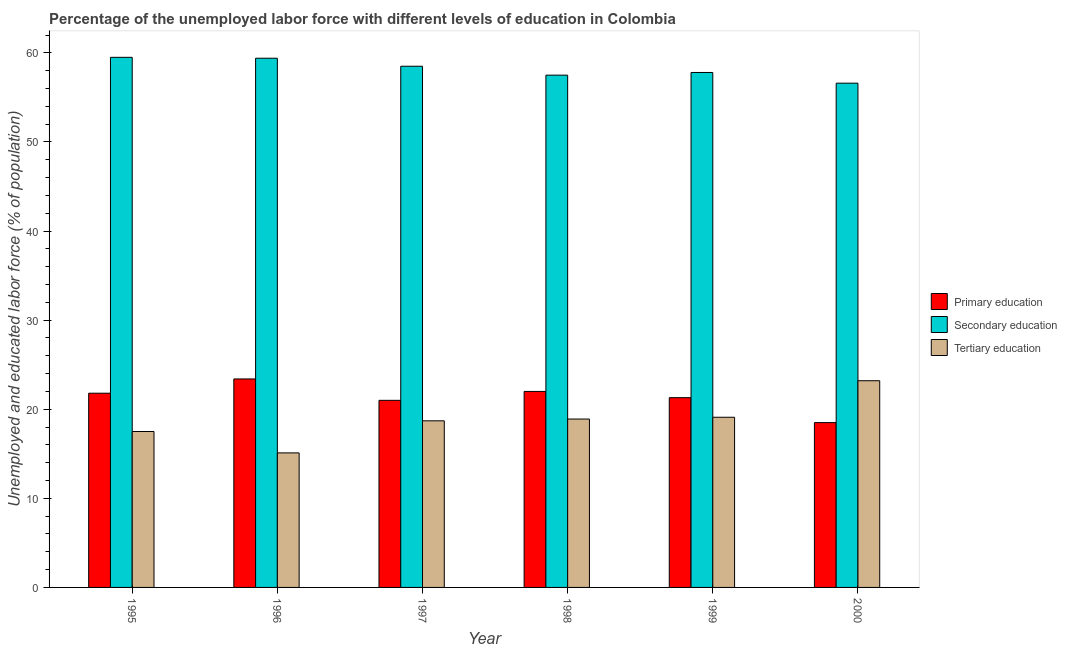How many different coloured bars are there?
Your response must be concise. 3. How many bars are there on the 1st tick from the right?
Provide a succinct answer. 3. What is the percentage of labor force who received tertiary education in 1997?
Provide a short and direct response. 18.7. Across all years, what is the maximum percentage of labor force who received tertiary education?
Ensure brevity in your answer.  23.2. Across all years, what is the minimum percentage of labor force who received primary education?
Offer a very short reply. 18.5. What is the total percentage of labor force who received secondary education in the graph?
Keep it short and to the point. 349.3. What is the difference between the percentage of labor force who received secondary education in 1995 and that in 2000?
Your response must be concise. 2.9. What is the difference between the percentage of labor force who received tertiary education in 2000 and the percentage of labor force who received primary education in 1995?
Offer a very short reply. 5.7. What is the average percentage of labor force who received tertiary education per year?
Offer a terse response. 18.75. In the year 1999, what is the difference between the percentage of labor force who received tertiary education and percentage of labor force who received secondary education?
Keep it short and to the point. 0. What is the ratio of the percentage of labor force who received secondary education in 1995 to that in 1999?
Offer a very short reply. 1.03. Is the percentage of labor force who received secondary education in 1995 less than that in 1996?
Keep it short and to the point. No. What is the difference between the highest and the second highest percentage of labor force who received primary education?
Keep it short and to the point. 1.4. What is the difference between the highest and the lowest percentage of labor force who received primary education?
Provide a succinct answer. 4.9. In how many years, is the percentage of labor force who received tertiary education greater than the average percentage of labor force who received tertiary education taken over all years?
Your answer should be compact. 3. Is the sum of the percentage of labor force who received primary education in 1995 and 1996 greater than the maximum percentage of labor force who received secondary education across all years?
Make the answer very short. Yes. What does the 2nd bar from the left in 1997 represents?
Keep it short and to the point. Secondary education. What does the 2nd bar from the right in 1998 represents?
Give a very brief answer. Secondary education. Is it the case that in every year, the sum of the percentage of labor force who received primary education and percentage of labor force who received secondary education is greater than the percentage of labor force who received tertiary education?
Your response must be concise. Yes. How many years are there in the graph?
Ensure brevity in your answer.  6. Are the values on the major ticks of Y-axis written in scientific E-notation?
Offer a terse response. No. Does the graph contain any zero values?
Your answer should be compact. No. Does the graph contain grids?
Offer a terse response. No. How many legend labels are there?
Your answer should be compact. 3. How are the legend labels stacked?
Your answer should be compact. Vertical. What is the title of the graph?
Offer a very short reply. Percentage of the unemployed labor force with different levels of education in Colombia. Does "Labor Market" appear as one of the legend labels in the graph?
Offer a very short reply. No. What is the label or title of the X-axis?
Your answer should be very brief. Year. What is the label or title of the Y-axis?
Ensure brevity in your answer.  Unemployed and educated labor force (% of population). What is the Unemployed and educated labor force (% of population) of Primary education in 1995?
Make the answer very short. 21.8. What is the Unemployed and educated labor force (% of population) in Secondary education in 1995?
Offer a terse response. 59.5. What is the Unemployed and educated labor force (% of population) of Tertiary education in 1995?
Make the answer very short. 17.5. What is the Unemployed and educated labor force (% of population) in Primary education in 1996?
Your answer should be compact. 23.4. What is the Unemployed and educated labor force (% of population) of Secondary education in 1996?
Ensure brevity in your answer.  59.4. What is the Unemployed and educated labor force (% of population) in Tertiary education in 1996?
Give a very brief answer. 15.1. What is the Unemployed and educated labor force (% of population) of Primary education in 1997?
Offer a very short reply. 21. What is the Unemployed and educated labor force (% of population) of Secondary education in 1997?
Your response must be concise. 58.5. What is the Unemployed and educated labor force (% of population) in Tertiary education in 1997?
Keep it short and to the point. 18.7. What is the Unemployed and educated labor force (% of population) in Primary education in 1998?
Provide a succinct answer. 22. What is the Unemployed and educated labor force (% of population) in Secondary education in 1998?
Make the answer very short. 57.5. What is the Unemployed and educated labor force (% of population) of Tertiary education in 1998?
Keep it short and to the point. 18.9. What is the Unemployed and educated labor force (% of population) in Primary education in 1999?
Keep it short and to the point. 21.3. What is the Unemployed and educated labor force (% of population) in Secondary education in 1999?
Ensure brevity in your answer.  57.8. What is the Unemployed and educated labor force (% of population) in Tertiary education in 1999?
Keep it short and to the point. 19.1. What is the Unemployed and educated labor force (% of population) of Primary education in 2000?
Keep it short and to the point. 18.5. What is the Unemployed and educated labor force (% of population) in Secondary education in 2000?
Make the answer very short. 56.6. What is the Unemployed and educated labor force (% of population) in Tertiary education in 2000?
Your response must be concise. 23.2. Across all years, what is the maximum Unemployed and educated labor force (% of population) in Primary education?
Your response must be concise. 23.4. Across all years, what is the maximum Unemployed and educated labor force (% of population) of Secondary education?
Make the answer very short. 59.5. Across all years, what is the maximum Unemployed and educated labor force (% of population) in Tertiary education?
Offer a very short reply. 23.2. Across all years, what is the minimum Unemployed and educated labor force (% of population) of Secondary education?
Make the answer very short. 56.6. Across all years, what is the minimum Unemployed and educated labor force (% of population) of Tertiary education?
Keep it short and to the point. 15.1. What is the total Unemployed and educated labor force (% of population) of Primary education in the graph?
Provide a succinct answer. 128. What is the total Unemployed and educated labor force (% of population) in Secondary education in the graph?
Offer a terse response. 349.3. What is the total Unemployed and educated labor force (% of population) in Tertiary education in the graph?
Give a very brief answer. 112.5. What is the difference between the Unemployed and educated labor force (% of population) in Primary education in 1995 and that in 1996?
Keep it short and to the point. -1.6. What is the difference between the Unemployed and educated labor force (% of population) of Tertiary education in 1995 and that in 1996?
Your answer should be compact. 2.4. What is the difference between the Unemployed and educated labor force (% of population) of Tertiary education in 1995 and that in 1997?
Offer a very short reply. -1.2. What is the difference between the Unemployed and educated labor force (% of population) of Primary education in 1995 and that in 1998?
Your answer should be very brief. -0.2. What is the difference between the Unemployed and educated labor force (% of population) in Secondary education in 1995 and that in 1999?
Keep it short and to the point. 1.7. What is the difference between the Unemployed and educated labor force (% of population) in Tertiary education in 1995 and that in 1999?
Ensure brevity in your answer.  -1.6. What is the difference between the Unemployed and educated labor force (% of population) in Primary education in 1995 and that in 2000?
Offer a very short reply. 3.3. What is the difference between the Unemployed and educated labor force (% of population) of Secondary education in 1995 and that in 2000?
Give a very brief answer. 2.9. What is the difference between the Unemployed and educated labor force (% of population) in Primary education in 1996 and that in 1997?
Provide a succinct answer. 2.4. What is the difference between the Unemployed and educated labor force (% of population) of Secondary education in 1996 and that in 1997?
Provide a succinct answer. 0.9. What is the difference between the Unemployed and educated labor force (% of population) of Primary education in 1996 and that in 1998?
Offer a terse response. 1.4. What is the difference between the Unemployed and educated labor force (% of population) of Secondary education in 1996 and that in 1998?
Offer a very short reply. 1.9. What is the difference between the Unemployed and educated labor force (% of population) in Primary education in 1996 and that in 1999?
Make the answer very short. 2.1. What is the difference between the Unemployed and educated labor force (% of population) of Secondary education in 1996 and that in 1999?
Your answer should be compact. 1.6. What is the difference between the Unemployed and educated labor force (% of population) of Tertiary education in 1996 and that in 1999?
Your response must be concise. -4. What is the difference between the Unemployed and educated labor force (% of population) of Primary education in 1996 and that in 2000?
Keep it short and to the point. 4.9. What is the difference between the Unemployed and educated labor force (% of population) of Secondary education in 1996 and that in 2000?
Give a very brief answer. 2.8. What is the difference between the Unemployed and educated labor force (% of population) in Primary education in 1997 and that in 1998?
Keep it short and to the point. -1. What is the difference between the Unemployed and educated labor force (% of population) of Tertiary education in 1997 and that in 1998?
Give a very brief answer. -0.2. What is the difference between the Unemployed and educated labor force (% of population) of Primary education in 1997 and that in 1999?
Your answer should be very brief. -0.3. What is the difference between the Unemployed and educated labor force (% of population) of Tertiary education in 1997 and that in 1999?
Keep it short and to the point. -0.4. What is the difference between the Unemployed and educated labor force (% of population) in Primary education in 1997 and that in 2000?
Provide a short and direct response. 2.5. What is the difference between the Unemployed and educated labor force (% of population) of Tertiary education in 1997 and that in 2000?
Keep it short and to the point. -4.5. What is the difference between the Unemployed and educated labor force (% of population) in Tertiary education in 1998 and that in 1999?
Your response must be concise. -0.2. What is the difference between the Unemployed and educated labor force (% of population) in Primary education in 1998 and that in 2000?
Keep it short and to the point. 3.5. What is the difference between the Unemployed and educated labor force (% of population) of Tertiary education in 1998 and that in 2000?
Make the answer very short. -4.3. What is the difference between the Unemployed and educated labor force (% of population) in Primary education in 1999 and that in 2000?
Provide a short and direct response. 2.8. What is the difference between the Unemployed and educated labor force (% of population) of Tertiary education in 1999 and that in 2000?
Keep it short and to the point. -4.1. What is the difference between the Unemployed and educated labor force (% of population) in Primary education in 1995 and the Unemployed and educated labor force (% of population) in Secondary education in 1996?
Provide a short and direct response. -37.6. What is the difference between the Unemployed and educated labor force (% of population) in Secondary education in 1995 and the Unemployed and educated labor force (% of population) in Tertiary education in 1996?
Offer a terse response. 44.4. What is the difference between the Unemployed and educated labor force (% of population) of Primary education in 1995 and the Unemployed and educated labor force (% of population) of Secondary education in 1997?
Provide a succinct answer. -36.7. What is the difference between the Unemployed and educated labor force (% of population) in Primary education in 1995 and the Unemployed and educated labor force (% of population) in Tertiary education in 1997?
Make the answer very short. 3.1. What is the difference between the Unemployed and educated labor force (% of population) in Secondary education in 1995 and the Unemployed and educated labor force (% of population) in Tertiary education in 1997?
Make the answer very short. 40.8. What is the difference between the Unemployed and educated labor force (% of population) of Primary education in 1995 and the Unemployed and educated labor force (% of population) of Secondary education in 1998?
Ensure brevity in your answer.  -35.7. What is the difference between the Unemployed and educated labor force (% of population) in Primary education in 1995 and the Unemployed and educated labor force (% of population) in Tertiary education in 1998?
Your answer should be very brief. 2.9. What is the difference between the Unemployed and educated labor force (% of population) of Secondary education in 1995 and the Unemployed and educated labor force (% of population) of Tertiary education in 1998?
Your answer should be very brief. 40.6. What is the difference between the Unemployed and educated labor force (% of population) of Primary education in 1995 and the Unemployed and educated labor force (% of population) of Secondary education in 1999?
Keep it short and to the point. -36. What is the difference between the Unemployed and educated labor force (% of population) in Secondary education in 1995 and the Unemployed and educated labor force (% of population) in Tertiary education in 1999?
Your response must be concise. 40.4. What is the difference between the Unemployed and educated labor force (% of population) in Primary education in 1995 and the Unemployed and educated labor force (% of population) in Secondary education in 2000?
Ensure brevity in your answer.  -34.8. What is the difference between the Unemployed and educated labor force (% of population) of Secondary education in 1995 and the Unemployed and educated labor force (% of population) of Tertiary education in 2000?
Your answer should be compact. 36.3. What is the difference between the Unemployed and educated labor force (% of population) in Primary education in 1996 and the Unemployed and educated labor force (% of population) in Secondary education in 1997?
Keep it short and to the point. -35.1. What is the difference between the Unemployed and educated labor force (% of population) of Secondary education in 1996 and the Unemployed and educated labor force (% of population) of Tertiary education in 1997?
Give a very brief answer. 40.7. What is the difference between the Unemployed and educated labor force (% of population) of Primary education in 1996 and the Unemployed and educated labor force (% of population) of Secondary education in 1998?
Your response must be concise. -34.1. What is the difference between the Unemployed and educated labor force (% of population) in Primary education in 1996 and the Unemployed and educated labor force (% of population) in Tertiary education in 1998?
Offer a very short reply. 4.5. What is the difference between the Unemployed and educated labor force (% of population) in Secondary education in 1996 and the Unemployed and educated labor force (% of population) in Tertiary education in 1998?
Give a very brief answer. 40.5. What is the difference between the Unemployed and educated labor force (% of population) in Primary education in 1996 and the Unemployed and educated labor force (% of population) in Secondary education in 1999?
Your response must be concise. -34.4. What is the difference between the Unemployed and educated labor force (% of population) of Primary education in 1996 and the Unemployed and educated labor force (% of population) of Tertiary education in 1999?
Offer a very short reply. 4.3. What is the difference between the Unemployed and educated labor force (% of population) of Secondary education in 1996 and the Unemployed and educated labor force (% of population) of Tertiary education in 1999?
Your answer should be very brief. 40.3. What is the difference between the Unemployed and educated labor force (% of population) in Primary education in 1996 and the Unemployed and educated labor force (% of population) in Secondary education in 2000?
Keep it short and to the point. -33.2. What is the difference between the Unemployed and educated labor force (% of population) of Primary education in 1996 and the Unemployed and educated labor force (% of population) of Tertiary education in 2000?
Offer a terse response. 0.2. What is the difference between the Unemployed and educated labor force (% of population) in Secondary education in 1996 and the Unemployed and educated labor force (% of population) in Tertiary education in 2000?
Your answer should be very brief. 36.2. What is the difference between the Unemployed and educated labor force (% of population) of Primary education in 1997 and the Unemployed and educated labor force (% of population) of Secondary education in 1998?
Ensure brevity in your answer.  -36.5. What is the difference between the Unemployed and educated labor force (% of population) in Secondary education in 1997 and the Unemployed and educated labor force (% of population) in Tertiary education in 1998?
Your response must be concise. 39.6. What is the difference between the Unemployed and educated labor force (% of population) in Primary education in 1997 and the Unemployed and educated labor force (% of population) in Secondary education in 1999?
Ensure brevity in your answer.  -36.8. What is the difference between the Unemployed and educated labor force (% of population) in Primary education in 1997 and the Unemployed and educated labor force (% of population) in Tertiary education in 1999?
Offer a very short reply. 1.9. What is the difference between the Unemployed and educated labor force (% of population) in Secondary education in 1997 and the Unemployed and educated labor force (% of population) in Tertiary education in 1999?
Offer a very short reply. 39.4. What is the difference between the Unemployed and educated labor force (% of population) of Primary education in 1997 and the Unemployed and educated labor force (% of population) of Secondary education in 2000?
Your response must be concise. -35.6. What is the difference between the Unemployed and educated labor force (% of population) in Primary education in 1997 and the Unemployed and educated labor force (% of population) in Tertiary education in 2000?
Offer a terse response. -2.2. What is the difference between the Unemployed and educated labor force (% of population) of Secondary education in 1997 and the Unemployed and educated labor force (% of population) of Tertiary education in 2000?
Offer a very short reply. 35.3. What is the difference between the Unemployed and educated labor force (% of population) in Primary education in 1998 and the Unemployed and educated labor force (% of population) in Secondary education in 1999?
Your answer should be very brief. -35.8. What is the difference between the Unemployed and educated labor force (% of population) in Primary education in 1998 and the Unemployed and educated labor force (% of population) in Tertiary education in 1999?
Ensure brevity in your answer.  2.9. What is the difference between the Unemployed and educated labor force (% of population) of Secondary education in 1998 and the Unemployed and educated labor force (% of population) of Tertiary education in 1999?
Keep it short and to the point. 38.4. What is the difference between the Unemployed and educated labor force (% of population) in Primary education in 1998 and the Unemployed and educated labor force (% of population) in Secondary education in 2000?
Offer a very short reply. -34.6. What is the difference between the Unemployed and educated labor force (% of population) of Secondary education in 1998 and the Unemployed and educated labor force (% of population) of Tertiary education in 2000?
Give a very brief answer. 34.3. What is the difference between the Unemployed and educated labor force (% of population) of Primary education in 1999 and the Unemployed and educated labor force (% of population) of Secondary education in 2000?
Make the answer very short. -35.3. What is the difference between the Unemployed and educated labor force (% of population) in Primary education in 1999 and the Unemployed and educated labor force (% of population) in Tertiary education in 2000?
Keep it short and to the point. -1.9. What is the difference between the Unemployed and educated labor force (% of population) of Secondary education in 1999 and the Unemployed and educated labor force (% of population) of Tertiary education in 2000?
Provide a short and direct response. 34.6. What is the average Unemployed and educated labor force (% of population) of Primary education per year?
Offer a terse response. 21.33. What is the average Unemployed and educated labor force (% of population) in Secondary education per year?
Offer a terse response. 58.22. What is the average Unemployed and educated labor force (% of population) in Tertiary education per year?
Ensure brevity in your answer.  18.75. In the year 1995, what is the difference between the Unemployed and educated labor force (% of population) in Primary education and Unemployed and educated labor force (% of population) in Secondary education?
Ensure brevity in your answer.  -37.7. In the year 1995, what is the difference between the Unemployed and educated labor force (% of population) of Secondary education and Unemployed and educated labor force (% of population) of Tertiary education?
Give a very brief answer. 42. In the year 1996, what is the difference between the Unemployed and educated labor force (% of population) of Primary education and Unemployed and educated labor force (% of population) of Secondary education?
Provide a succinct answer. -36. In the year 1996, what is the difference between the Unemployed and educated labor force (% of population) of Secondary education and Unemployed and educated labor force (% of population) of Tertiary education?
Offer a terse response. 44.3. In the year 1997, what is the difference between the Unemployed and educated labor force (% of population) of Primary education and Unemployed and educated labor force (% of population) of Secondary education?
Give a very brief answer. -37.5. In the year 1997, what is the difference between the Unemployed and educated labor force (% of population) in Primary education and Unemployed and educated labor force (% of population) in Tertiary education?
Make the answer very short. 2.3. In the year 1997, what is the difference between the Unemployed and educated labor force (% of population) in Secondary education and Unemployed and educated labor force (% of population) in Tertiary education?
Provide a short and direct response. 39.8. In the year 1998, what is the difference between the Unemployed and educated labor force (% of population) in Primary education and Unemployed and educated labor force (% of population) in Secondary education?
Offer a terse response. -35.5. In the year 1998, what is the difference between the Unemployed and educated labor force (% of population) in Secondary education and Unemployed and educated labor force (% of population) in Tertiary education?
Ensure brevity in your answer.  38.6. In the year 1999, what is the difference between the Unemployed and educated labor force (% of population) of Primary education and Unemployed and educated labor force (% of population) of Secondary education?
Keep it short and to the point. -36.5. In the year 1999, what is the difference between the Unemployed and educated labor force (% of population) in Primary education and Unemployed and educated labor force (% of population) in Tertiary education?
Give a very brief answer. 2.2. In the year 1999, what is the difference between the Unemployed and educated labor force (% of population) of Secondary education and Unemployed and educated labor force (% of population) of Tertiary education?
Keep it short and to the point. 38.7. In the year 2000, what is the difference between the Unemployed and educated labor force (% of population) in Primary education and Unemployed and educated labor force (% of population) in Secondary education?
Your answer should be compact. -38.1. In the year 2000, what is the difference between the Unemployed and educated labor force (% of population) of Primary education and Unemployed and educated labor force (% of population) of Tertiary education?
Offer a very short reply. -4.7. In the year 2000, what is the difference between the Unemployed and educated labor force (% of population) in Secondary education and Unemployed and educated labor force (% of population) in Tertiary education?
Keep it short and to the point. 33.4. What is the ratio of the Unemployed and educated labor force (% of population) of Primary education in 1995 to that in 1996?
Your answer should be very brief. 0.93. What is the ratio of the Unemployed and educated labor force (% of population) of Secondary education in 1995 to that in 1996?
Your answer should be very brief. 1. What is the ratio of the Unemployed and educated labor force (% of population) of Tertiary education in 1995 to that in 1996?
Your answer should be very brief. 1.16. What is the ratio of the Unemployed and educated labor force (% of population) of Primary education in 1995 to that in 1997?
Offer a terse response. 1.04. What is the ratio of the Unemployed and educated labor force (% of population) in Secondary education in 1995 to that in 1997?
Your answer should be compact. 1.02. What is the ratio of the Unemployed and educated labor force (% of population) in Tertiary education in 1995 to that in 1997?
Your answer should be compact. 0.94. What is the ratio of the Unemployed and educated labor force (% of population) of Primary education in 1995 to that in 1998?
Keep it short and to the point. 0.99. What is the ratio of the Unemployed and educated labor force (% of population) of Secondary education in 1995 to that in 1998?
Give a very brief answer. 1.03. What is the ratio of the Unemployed and educated labor force (% of population) of Tertiary education in 1995 to that in 1998?
Ensure brevity in your answer.  0.93. What is the ratio of the Unemployed and educated labor force (% of population) of Primary education in 1995 to that in 1999?
Your response must be concise. 1.02. What is the ratio of the Unemployed and educated labor force (% of population) of Secondary education in 1995 to that in 1999?
Ensure brevity in your answer.  1.03. What is the ratio of the Unemployed and educated labor force (% of population) in Tertiary education in 1995 to that in 1999?
Give a very brief answer. 0.92. What is the ratio of the Unemployed and educated labor force (% of population) in Primary education in 1995 to that in 2000?
Your answer should be compact. 1.18. What is the ratio of the Unemployed and educated labor force (% of population) of Secondary education in 1995 to that in 2000?
Your answer should be compact. 1.05. What is the ratio of the Unemployed and educated labor force (% of population) in Tertiary education in 1995 to that in 2000?
Make the answer very short. 0.75. What is the ratio of the Unemployed and educated labor force (% of population) in Primary education in 1996 to that in 1997?
Ensure brevity in your answer.  1.11. What is the ratio of the Unemployed and educated labor force (% of population) in Secondary education in 1996 to that in 1997?
Offer a very short reply. 1.02. What is the ratio of the Unemployed and educated labor force (% of population) in Tertiary education in 1996 to that in 1997?
Your response must be concise. 0.81. What is the ratio of the Unemployed and educated labor force (% of population) in Primary education in 1996 to that in 1998?
Ensure brevity in your answer.  1.06. What is the ratio of the Unemployed and educated labor force (% of population) of Secondary education in 1996 to that in 1998?
Your answer should be very brief. 1.03. What is the ratio of the Unemployed and educated labor force (% of population) in Tertiary education in 1996 to that in 1998?
Provide a succinct answer. 0.8. What is the ratio of the Unemployed and educated labor force (% of population) of Primary education in 1996 to that in 1999?
Give a very brief answer. 1.1. What is the ratio of the Unemployed and educated labor force (% of population) of Secondary education in 1996 to that in 1999?
Your response must be concise. 1.03. What is the ratio of the Unemployed and educated labor force (% of population) in Tertiary education in 1996 to that in 1999?
Offer a very short reply. 0.79. What is the ratio of the Unemployed and educated labor force (% of population) in Primary education in 1996 to that in 2000?
Your answer should be compact. 1.26. What is the ratio of the Unemployed and educated labor force (% of population) in Secondary education in 1996 to that in 2000?
Your answer should be compact. 1.05. What is the ratio of the Unemployed and educated labor force (% of population) of Tertiary education in 1996 to that in 2000?
Make the answer very short. 0.65. What is the ratio of the Unemployed and educated labor force (% of population) of Primary education in 1997 to that in 1998?
Your answer should be very brief. 0.95. What is the ratio of the Unemployed and educated labor force (% of population) in Secondary education in 1997 to that in 1998?
Ensure brevity in your answer.  1.02. What is the ratio of the Unemployed and educated labor force (% of population) in Primary education in 1997 to that in 1999?
Provide a short and direct response. 0.99. What is the ratio of the Unemployed and educated labor force (% of population) in Secondary education in 1997 to that in 1999?
Offer a very short reply. 1.01. What is the ratio of the Unemployed and educated labor force (% of population) of Tertiary education in 1997 to that in 1999?
Ensure brevity in your answer.  0.98. What is the ratio of the Unemployed and educated labor force (% of population) in Primary education in 1997 to that in 2000?
Your answer should be compact. 1.14. What is the ratio of the Unemployed and educated labor force (% of population) in Secondary education in 1997 to that in 2000?
Provide a short and direct response. 1.03. What is the ratio of the Unemployed and educated labor force (% of population) in Tertiary education in 1997 to that in 2000?
Provide a short and direct response. 0.81. What is the ratio of the Unemployed and educated labor force (% of population) in Primary education in 1998 to that in 1999?
Make the answer very short. 1.03. What is the ratio of the Unemployed and educated labor force (% of population) in Secondary education in 1998 to that in 1999?
Offer a very short reply. 0.99. What is the ratio of the Unemployed and educated labor force (% of population) of Tertiary education in 1998 to that in 1999?
Your response must be concise. 0.99. What is the ratio of the Unemployed and educated labor force (% of population) of Primary education in 1998 to that in 2000?
Offer a very short reply. 1.19. What is the ratio of the Unemployed and educated labor force (% of population) in Secondary education in 1998 to that in 2000?
Provide a succinct answer. 1.02. What is the ratio of the Unemployed and educated labor force (% of population) in Tertiary education in 1998 to that in 2000?
Ensure brevity in your answer.  0.81. What is the ratio of the Unemployed and educated labor force (% of population) of Primary education in 1999 to that in 2000?
Provide a succinct answer. 1.15. What is the ratio of the Unemployed and educated labor force (% of population) of Secondary education in 1999 to that in 2000?
Give a very brief answer. 1.02. What is the ratio of the Unemployed and educated labor force (% of population) in Tertiary education in 1999 to that in 2000?
Provide a short and direct response. 0.82. What is the difference between the highest and the second highest Unemployed and educated labor force (% of population) of Primary education?
Your answer should be compact. 1.4. What is the difference between the highest and the second highest Unemployed and educated labor force (% of population) in Tertiary education?
Provide a succinct answer. 4.1. What is the difference between the highest and the lowest Unemployed and educated labor force (% of population) of Primary education?
Offer a terse response. 4.9. 